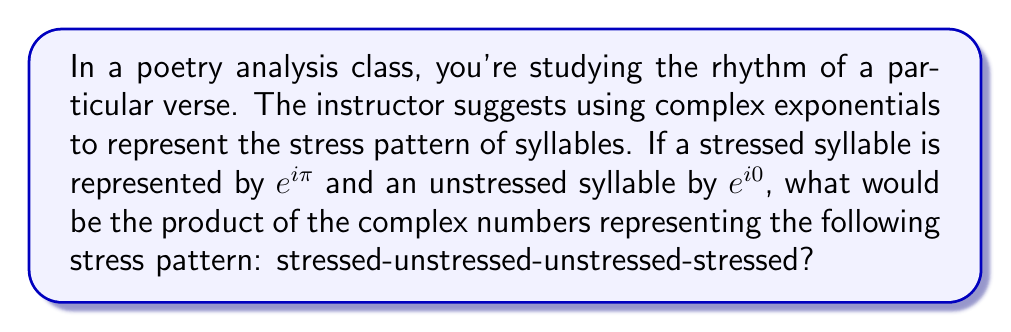Show me your answer to this math problem. Let's approach this step-by-step:

1) First, let's recall what each symbol represents:
   - Stressed syllable: $e^{i\pi}$
   - Unstressed syllable: $e^{i0}$

2) The pattern we're looking at is: stressed-unstressed-unstressed-stressed
   So, we need to multiply: $e^{i\pi} \cdot e^{i0} \cdot e^{i0} \cdot e^{i\pi}$

3) Let's simplify this:
   $$(e^{i\pi})(e^{i0})(e^{i0})(e^{i\pi}) = e^{i\pi} \cdot 1 \cdot 1 \cdot e^{i\pi}$$

4) This simplifies to:
   $$e^{i\pi} \cdot e^{i\pi} = e^{i2\pi}$$

5) Now, recall Euler's formula: $e^{ix} = \cos x + i \sin x$

6) Applying this to our result:
   $$e^{i2\pi} = \cos 2\pi + i \sin 2\pi$$

7) We know that $\cos 2\pi = 1$ and $\sin 2\pi = 0$, so:
   $$e^{i2\pi} = 1 + i0 = 1$$

Therefore, the product of the complex numbers representing this stress pattern is 1.
Answer: 1 